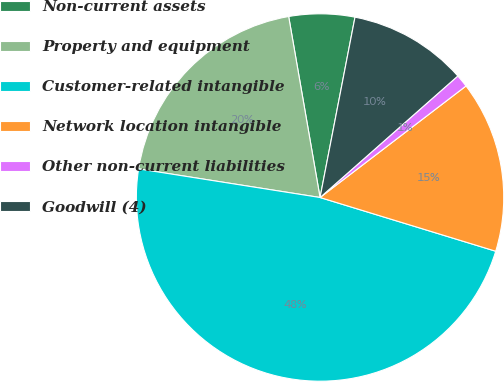Convert chart. <chart><loc_0><loc_0><loc_500><loc_500><pie_chart><fcel>Non-current assets<fcel>Property and equipment<fcel>Customer-related intangible<fcel>Network location intangible<fcel>Other non-current liabilities<fcel>Goodwill (4)<nl><fcel>5.78%<fcel>19.78%<fcel>47.77%<fcel>15.11%<fcel>1.12%<fcel>10.45%<nl></chart> 